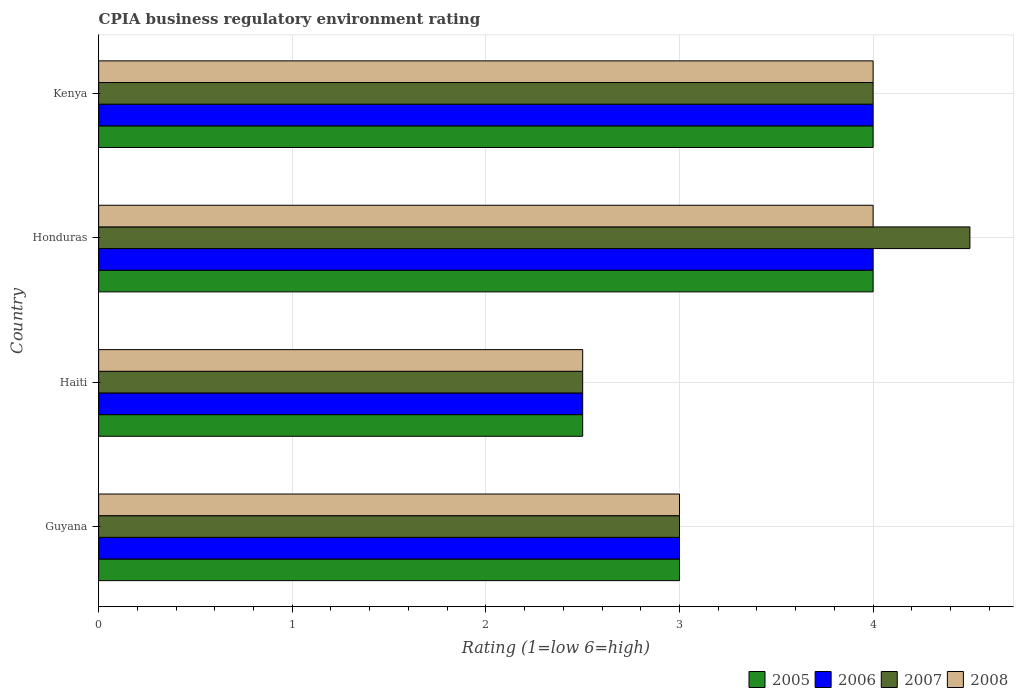What is the label of the 3rd group of bars from the top?
Your answer should be compact. Haiti. What is the CPIA rating in 2007 in Honduras?
Your answer should be very brief. 4.5. Across all countries, what is the minimum CPIA rating in 2007?
Make the answer very short. 2.5. In which country was the CPIA rating in 2005 maximum?
Give a very brief answer. Honduras. In which country was the CPIA rating in 2007 minimum?
Ensure brevity in your answer.  Haiti. What is the difference between the CPIA rating in 2006 in Guyana and that in Haiti?
Offer a terse response. 0.5. What is the difference between the CPIA rating in 2006 in Guyana and the CPIA rating in 2005 in Haiti?
Your answer should be very brief. 0.5. What is the average CPIA rating in 2006 per country?
Give a very brief answer. 3.38. Is the sum of the CPIA rating in 2005 in Haiti and Kenya greater than the maximum CPIA rating in 2008 across all countries?
Offer a terse response. Yes. Is it the case that in every country, the sum of the CPIA rating in 2008 and CPIA rating in 2007 is greater than the sum of CPIA rating in 2006 and CPIA rating in 2005?
Offer a very short reply. No. Is it the case that in every country, the sum of the CPIA rating in 2008 and CPIA rating in 2006 is greater than the CPIA rating in 2005?
Make the answer very short. Yes. How many countries are there in the graph?
Offer a terse response. 4. Does the graph contain any zero values?
Your answer should be compact. No. Does the graph contain grids?
Your answer should be compact. Yes. Where does the legend appear in the graph?
Provide a short and direct response. Bottom right. How are the legend labels stacked?
Provide a succinct answer. Horizontal. What is the title of the graph?
Your answer should be very brief. CPIA business regulatory environment rating. What is the label or title of the X-axis?
Your answer should be compact. Rating (1=low 6=high). What is the Rating (1=low 6=high) of 2006 in Guyana?
Offer a terse response. 3. What is the Rating (1=low 6=high) in 2008 in Guyana?
Keep it short and to the point. 3. What is the Rating (1=low 6=high) in 2005 in Haiti?
Offer a very short reply. 2.5. What is the Rating (1=low 6=high) in 2005 in Honduras?
Keep it short and to the point. 4. What is the Rating (1=low 6=high) in 2006 in Honduras?
Offer a terse response. 4. What is the Rating (1=low 6=high) of 2007 in Honduras?
Offer a very short reply. 4.5. What is the Rating (1=low 6=high) of 2008 in Honduras?
Provide a short and direct response. 4. Across all countries, what is the maximum Rating (1=low 6=high) in 2005?
Give a very brief answer. 4. Across all countries, what is the maximum Rating (1=low 6=high) in 2007?
Offer a terse response. 4.5. Across all countries, what is the minimum Rating (1=low 6=high) in 2006?
Your response must be concise. 2.5. Across all countries, what is the minimum Rating (1=low 6=high) in 2007?
Your response must be concise. 2.5. Across all countries, what is the minimum Rating (1=low 6=high) of 2008?
Offer a very short reply. 2.5. What is the total Rating (1=low 6=high) of 2006 in the graph?
Your answer should be compact. 13.5. What is the total Rating (1=low 6=high) of 2007 in the graph?
Provide a succinct answer. 14. What is the total Rating (1=low 6=high) of 2008 in the graph?
Your response must be concise. 13.5. What is the difference between the Rating (1=low 6=high) in 2005 in Guyana and that in Haiti?
Your answer should be very brief. 0.5. What is the difference between the Rating (1=low 6=high) in 2006 in Guyana and that in Haiti?
Your answer should be compact. 0.5. What is the difference between the Rating (1=low 6=high) of 2007 in Guyana and that in Haiti?
Offer a terse response. 0.5. What is the difference between the Rating (1=low 6=high) of 2006 in Guyana and that in Honduras?
Provide a succinct answer. -1. What is the difference between the Rating (1=low 6=high) in 2008 in Guyana and that in Honduras?
Offer a terse response. -1. What is the difference between the Rating (1=low 6=high) in 2005 in Guyana and that in Kenya?
Offer a terse response. -1. What is the difference between the Rating (1=low 6=high) in 2008 in Guyana and that in Kenya?
Provide a succinct answer. -1. What is the difference between the Rating (1=low 6=high) of 2006 in Haiti and that in Honduras?
Provide a succinct answer. -1.5. What is the difference between the Rating (1=low 6=high) of 2005 in Haiti and that in Kenya?
Your response must be concise. -1.5. What is the difference between the Rating (1=low 6=high) of 2006 in Haiti and that in Kenya?
Offer a very short reply. -1.5. What is the difference between the Rating (1=low 6=high) of 2007 in Haiti and that in Kenya?
Provide a succinct answer. -1.5. What is the difference between the Rating (1=low 6=high) of 2008 in Haiti and that in Kenya?
Ensure brevity in your answer.  -1.5. What is the difference between the Rating (1=low 6=high) of 2005 in Honduras and that in Kenya?
Offer a very short reply. 0. What is the difference between the Rating (1=low 6=high) in 2007 in Honduras and that in Kenya?
Your answer should be very brief. 0.5. What is the difference between the Rating (1=low 6=high) in 2005 in Guyana and the Rating (1=low 6=high) in 2006 in Haiti?
Your answer should be compact. 0.5. What is the difference between the Rating (1=low 6=high) of 2005 in Guyana and the Rating (1=low 6=high) of 2008 in Haiti?
Give a very brief answer. 0.5. What is the difference between the Rating (1=low 6=high) of 2006 in Guyana and the Rating (1=low 6=high) of 2007 in Haiti?
Provide a succinct answer. 0.5. What is the difference between the Rating (1=low 6=high) in 2006 in Guyana and the Rating (1=low 6=high) in 2008 in Haiti?
Your answer should be compact. 0.5. What is the difference between the Rating (1=low 6=high) of 2007 in Guyana and the Rating (1=low 6=high) of 2008 in Haiti?
Your answer should be compact. 0.5. What is the difference between the Rating (1=low 6=high) in 2005 in Guyana and the Rating (1=low 6=high) in 2008 in Honduras?
Ensure brevity in your answer.  -1. What is the difference between the Rating (1=low 6=high) of 2006 in Guyana and the Rating (1=low 6=high) of 2008 in Honduras?
Your response must be concise. -1. What is the difference between the Rating (1=low 6=high) of 2006 in Guyana and the Rating (1=low 6=high) of 2007 in Kenya?
Your answer should be compact. -1. What is the difference between the Rating (1=low 6=high) of 2007 in Guyana and the Rating (1=low 6=high) of 2008 in Kenya?
Make the answer very short. -1. What is the difference between the Rating (1=low 6=high) of 2005 in Haiti and the Rating (1=low 6=high) of 2007 in Honduras?
Provide a succinct answer. -2. What is the difference between the Rating (1=low 6=high) in 2005 in Haiti and the Rating (1=low 6=high) in 2008 in Honduras?
Make the answer very short. -1.5. What is the difference between the Rating (1=low 6=high) in 2006 in Haiti and the Rating (1=low 6=high) in 2007 in Honduras?
Give a very brief answer. -2. What is the difference between the Rating (1=low 6=high) in 2006 in Haiti and the Rating (1=low 6=high) in 2008 in Honduras?
Make the answer very short. -1.5. What is the difference between the Rating (1=low 6=high) of 2005 in Haiti and the Rating (1=low 6=high) of 2007 in Kenya?
Give a very brief answer. -1.5. What is the difference between the Rating (1=low 6=high) in 2005 in Haiti and the Rating (1=low 6=high) in 2008 in Kenya?
Offer a very short reply. -1.5. What is the difference between the Rating (1=low 6=high) of 2006 in Haiti and the Rating (1=low 6=high) of 2007 in Kenya?
Give a very brief answer. -1.5. What is the difference between the Rating (1=low 6=high) of 2006 in Haiti and the Rating (1=low 6=high) of 2008 in Kenya?
Keep it short and to the point. -1.5. What is the difference between the Rating (1=low 6=high) in 2005 in Honduras and the Rating (1=low 6=high) in 2006 in Kenya?
Your answer should be compact. 0. What is the difference between the Rating (1=low 6=high) in 2005 in Honduras and the Rating (1=low 6=high) in 2008 in Kenya?
Offer a very short reply. 0. What is the difference between the Rating (1=low 6=high) of 2006 in Honduras and the Rating (1=low 6=high) of 2007 in Kenya?
Give a very brief answer. 0. What is the difference between the Rating (1=low 6=high) of 2006 in Honduras and the Rating (1=low 6=high) of 2008 in Kenya?
Your answer should be very brief. 0. What is the difference between the Rating (1=low 6=high) of 2007 in Honduras and the Rating (1=low 6=high) of 2008 in Kenya?
Ensure brevity in your answer.  0.5. What is the average Rating (1=low 6=high) in 2005 per country?
Your answer should be compact. 3.38. What is the average Rating (1=low 6=high) of 2006 per country?
Provide a succinct answer. 3.38. What is the average Rating (1=low 6=high) of 2007 per country?
Your response must be concise. 3.5. What is the average Rating (1=low 6=high) of 2008 per country?
Your answer should be very brief. 3.38. What is the difference between the Rating (1=low 6=high) in 2006 and Rating (1=low 6=high) in 2007 in Guyana?
Provide a succinct answer. 0. What is the difference between the Rating (1=low 6=high) of 2007 and Rating (1=low 6=high) of 2008 in Guyana?
Your answer should be compact. 0. What is the difference between the Rating (1=low 6=high) of 2005 and Rating (1=low 6=high) of 2006 in Haiti?
Give a very brief answer. 0. What is the difference between the Rating (1=low 6=high) of 2005 and Rating (1=low 6=high) of 2007 in Haiti?
Make the answer very short. 0. What is the difference between the Rating (1=low 6=high) of 2005 and Rating (1=low 6=high) of 2008 in Haiti?
Ensure brevity in your answer.  0. What is the difference between the Rating (1=low 6=high) of 2006 and Rating (1=low 6=high) of 2007 in Haiti?
Offer a terse response. 0. What is the difference between the Rating (1=low 6=high) of 2005 and Rating (1=low 6=high) of 2006 in Honduras?
Make the answer very short. 0. What is the difference between the Rating (1=low 6=high) of 2005 and Rating (1=low 6=high) of 2007 in Honduras?
Offer a very short reply. -0.5. What is the difference between the Rating (1=low 6=high) of 2005 and Rating (1=low 6=high) of 2006 in Kenya?
Ensure brevity in your answer.  0. What is the difference between the Rating (1=low 6=high) of 2007 and Rating (1=low 6=high) of 2008 in Kenya?
Ensure brevity in your answer.  0. What is the ratio of the Rating (1=low 6=high) in 2006 in Guyana to that in Haiti?
Offer a very short reply. 1.2. What is the ratio of the Rating (1=low 6=high) in 2007 in Guyana to that in Haiti?
Provide a succinct answer. 1.2. What is the ratio of the Rating (1=low 6=high) in 2007 in Guyana to that in Honduras?
Your response must be concise. 0.67. What is the ratio of the Rating (1=low 6=high) of 2005 in Guyana to that in Kenya?
Offer a very short reply. 0.75. What is the ratio of the Rating (1=low 6=high) in 2006 in Guyana to that in Kenya?
Your answer should be very brief. 0.75. What is the ratio of the Rating (1=low 6=high) in 2007 in Guyana to that in Kenya?
Your answer should be very brief. 0.75. What is the ratio of the Rating (1=low 6=high) of 2006 in Haiti to that in Honduras?
Ensure brevity in your answer.  0.62. What is the ratio of the Rating (1=low 6=high) of 2007 in Haiti to that in Honduras?
Provide a short and direct response. 0.56. What is the ratio of the Rating (1=low 6=high) of 2008 in Haiti to that in Kenya?
Ensure brevity in your answer.  0.62. What is the ratio of the Rating (1=low 6=high) in 2005 in Honduras to that in Kenya?
Keep it short and to the point. 1. What is the ratio of the Rating (1=low 6=high) in 2008 in Honduras to that in Kenya?
Provide a short and direct response. 1. What is the difference between the highest and the second highest Rating (1=low 6=high) of 2007?
Provide a succinct answer. 0.5. What is the difference between the highest and the lowest Rating (1=low 6=high) of 2005?
Offer a very short reply. 1.5. What is the difference between the highest and the lowest Rating (1=low 6=high) in 2006?
Your answer should be very brief. 1.5. What is the difference between the highest and the lowest Rating (1=low 6=high) of 2007?
Keep it short and to the point. 2. 